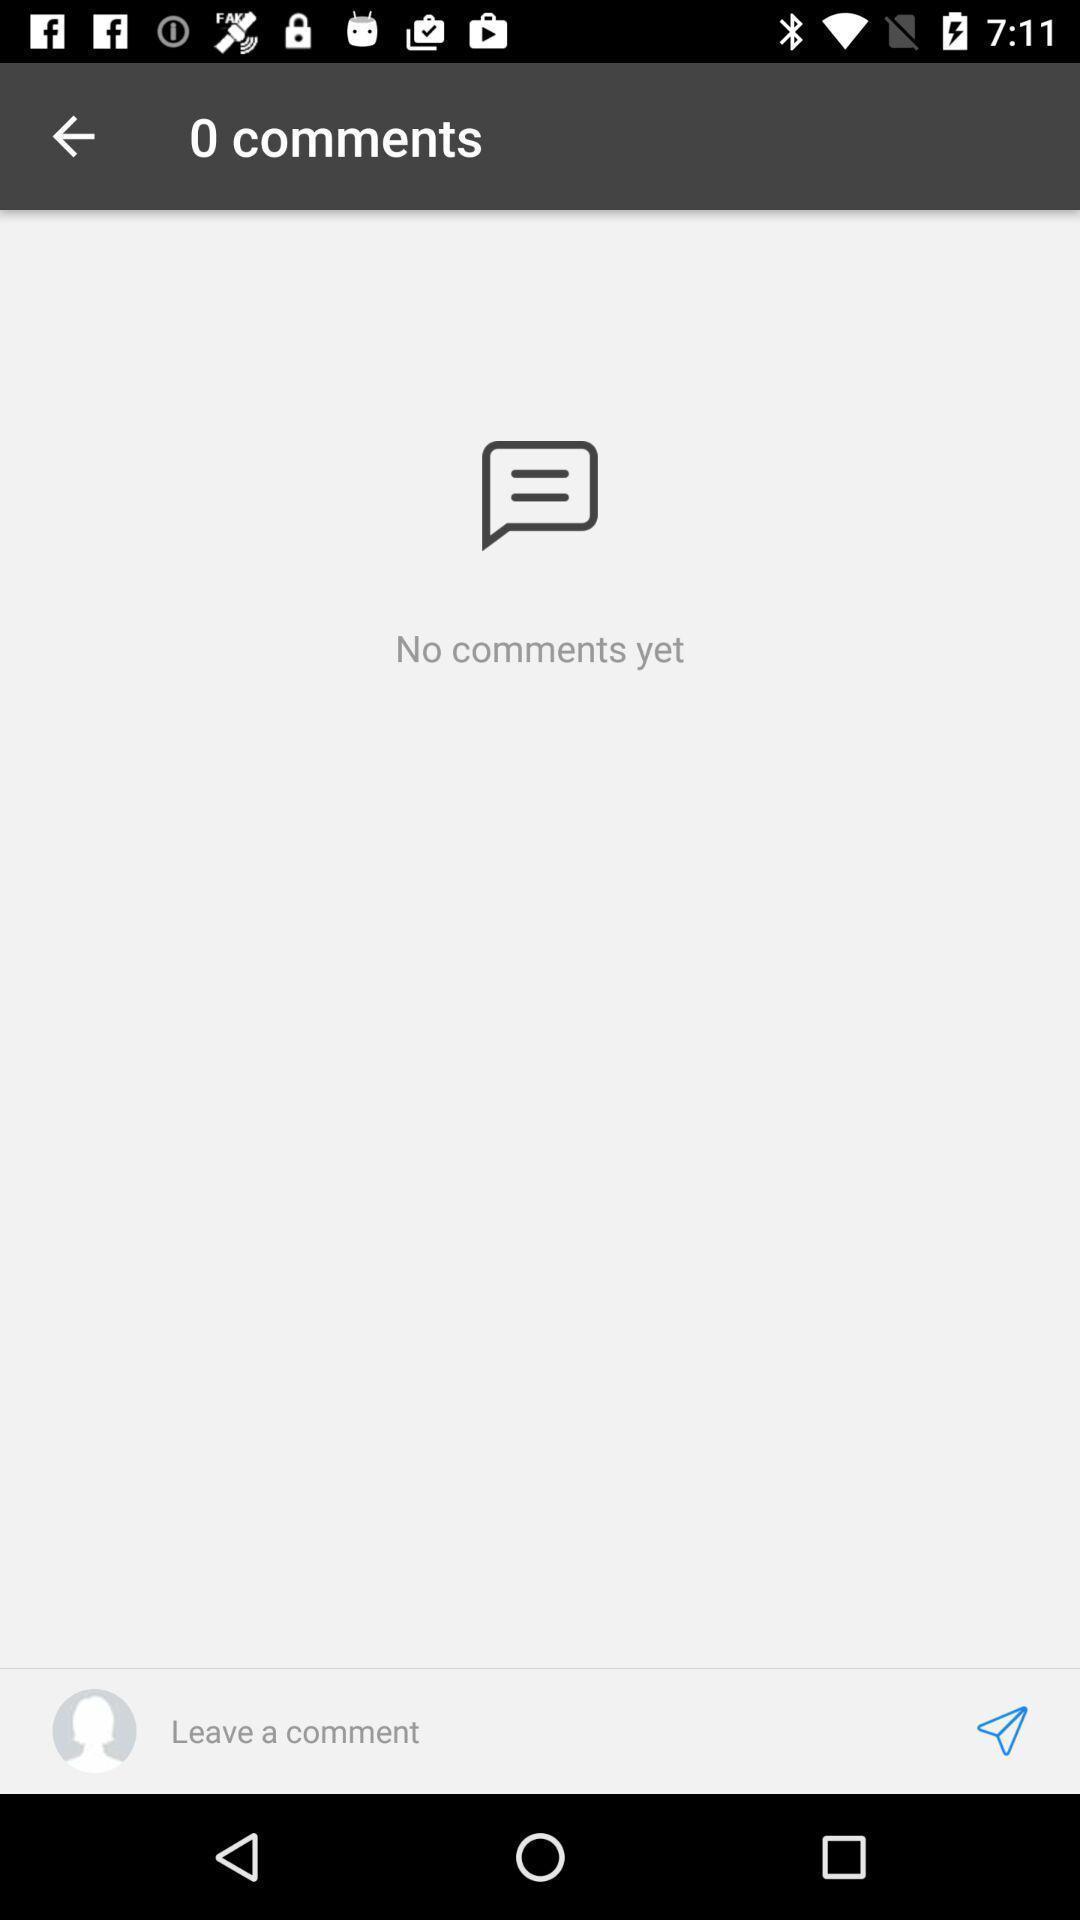Describe the key features of this screenshot. Screen shows comment details. 